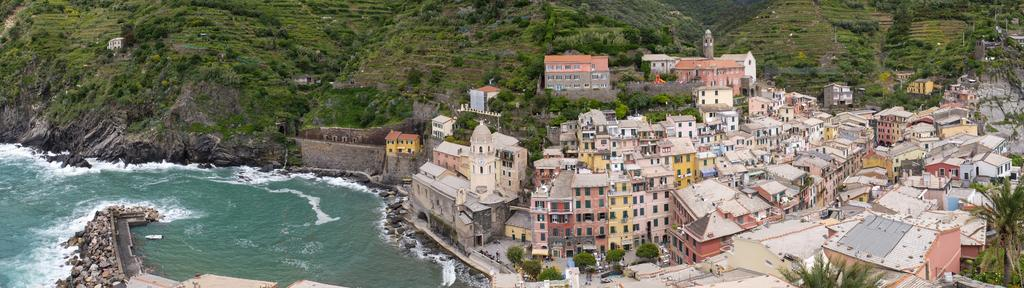What type of structures can be seen in the image? There are houses in the image. What natural feature is visible in the image? The sea is visible in the image. What geographical feature is present in the image? There is a mountain in the image. What type of vegetation is on the mountain? Trees are present on the mountain. What is the average income of the people living in the houses in the image? There is no information about the income of the people living in the houses in the image. How many chairs are visible in the image? There are no chairs present in the image. 